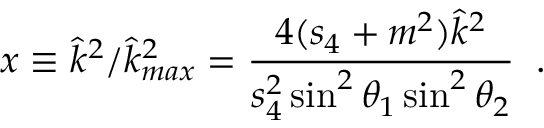<formula> <loc_0><loc_0><loc_500><loc_500>x \equiv \hat { k } ^ { 2 } / \hat { k } _ { \max } ^ { 2 } = \frac { 4 ( s _ { 4 } + m ^ { 2 } ) \hat { k } ^ { 2 } } { s _ { 4 } ^ { 2 } \sin ^ { 2 } \theta _ { 1 } \sin ^ { 2 } \theta _ { 2 } } \, .</formula> 